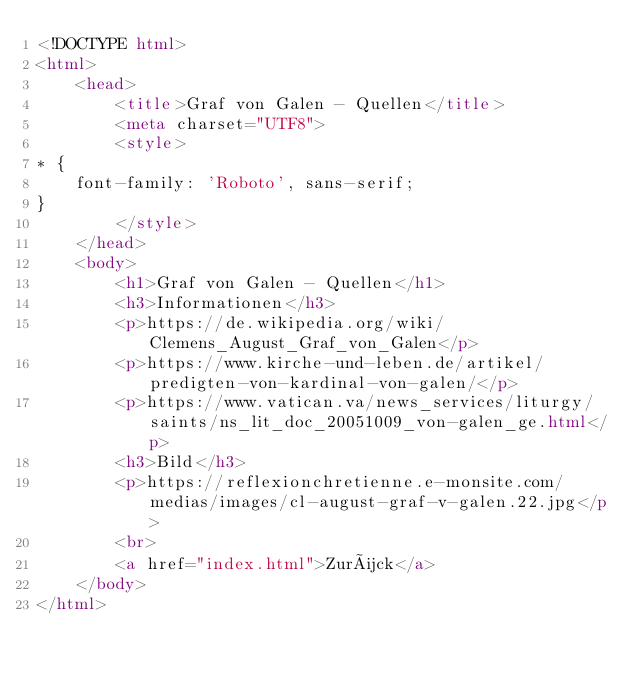Convert code to text. <code><loc_0><loc_0><loc_500><loc_500><_HTML_><!DOCTYPE html>
<html>
    <head>
        <title>Graf von Galen - Quellen</title>
        <meta charset="UTF8">
        <style>
* {
    font-family: 'Roboto', sans-serif;
}
        </style>
    </head>
    <body>
        <h1>Graf von Galen - Quellen</h1>
        <h3>Informationen</h3>
        <p>https://de.wikipedia.org/wiki/Clemens_August_Graf_von_Galen</p>
        <p>https://www.kirche-und-leben.de/artikel/predigten-von-kardinal-von-galen/</p>
        <p>https://www.vatican.va/news_services/liturgy/saints/ns_lit_doc_20051009_von-galen_ge.html</p>
        <h3>Bild</h3>
        <p>https://reflexionchretienne.e-monsite.com/medias/images/cl-august-graf-v-galen.22.jpg</p>
        <br>
        <a href="index.html">Zurück</a>
    </body>
</html>
</code> 